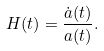<formula> <loc_0><loc_0><loc_500><loc_500>H ( t ) = \frac { { \dot { a } ( t ) } } { a ( t ) } .</formula> 